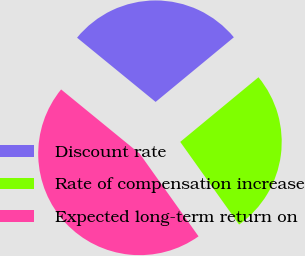Convert chart to OTSL. <chart><loc_0><loc_0><loc_500><loc_500><pie_chart><fcel>Discount rate<fcel>Rate of compensation increase<fcel>Expected long-term return on<nl><fcel>28.1%<fcel>26.14%<fcel>45.75%<nl></chart> 